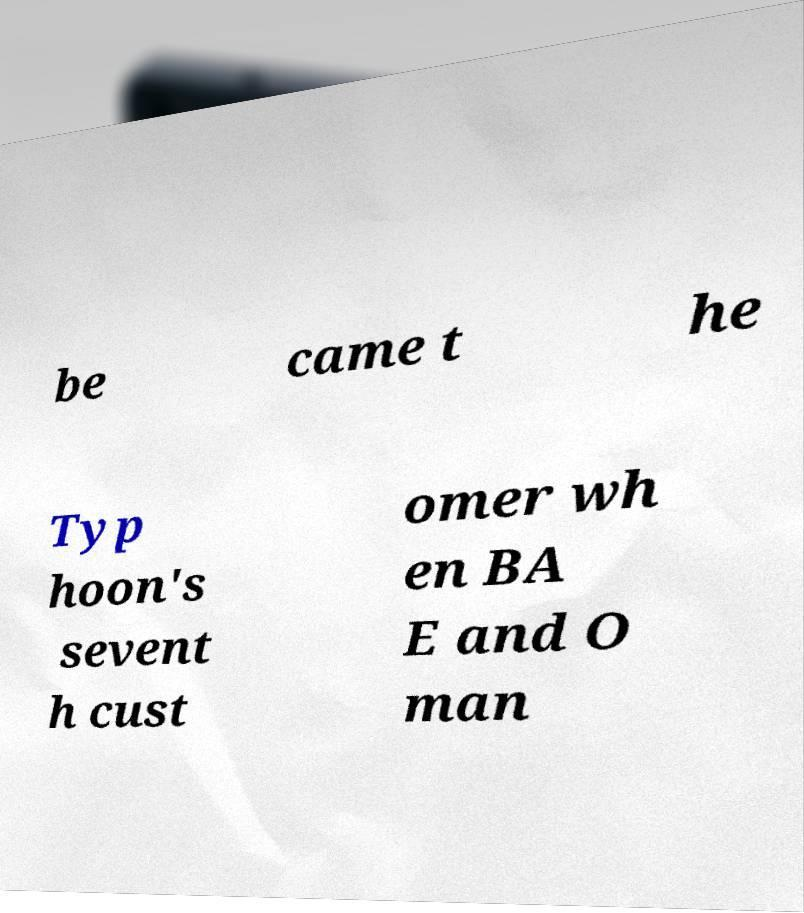Please identify and transcribe the text found in this image. be came t he Typ hoon's sevent h cust omer wh en BA E and O man 